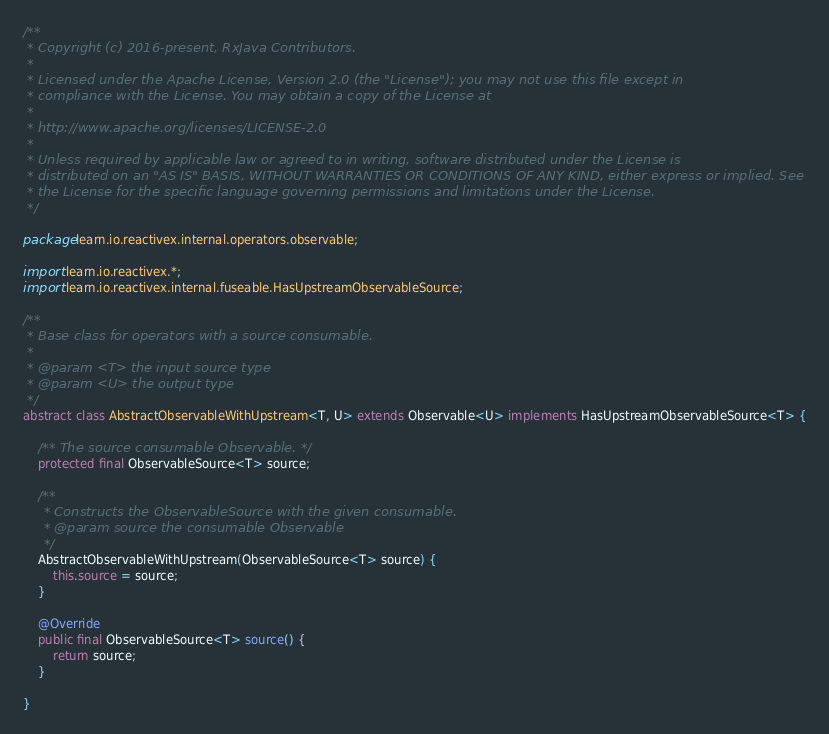Convert code to text. <code><loc_0><loc_0><loc_500><loc_500><_Java_>/**
 * Copyright (c) 2016-present, RxJava Contributors.
 *
 * Licensed under the Apache License, Version 2.0 (the "License"); you may not use this file except in
 * compliance with the License. You may obtain a copy of the License at
 *
 * http://www.apache.org/licenses/LICENSE-2.0
 *
 * Unless required by applicable law or agreed to in writing, software distributed under the License is
 * distributed on an "AS IS" BASIS, WITHOUT WARRANTIES OR CONDITIONS OF ANY KIND, either express or implied. See
 * the License for the specific language governing permissions and limitations under the License.
 */

package learn.io.reactivex.internal.operators.observable;

import learn.io.reactivex.*;
import learn.io.reactivex.internal.fuseable.HasUpstreamObservableSource;

/**
 * Base class for operators with a source consumable.
 *
 * @param <T> the input source type
 * @param <U> the output type
 */
abstract class AbstractObservableWithUpstream<T, U> extends Observable<U> implements HasUpstreamObservableSource<T> {

    /** The source consumable Observable. */
    protected final ObservableSource<T> source;

    /**
     * Constructs the ObservableSource with the given consumable.
     * @param source the consumable Observable
     */
    AbstractObservableWithUpstream(ObservableSource<T> source) {
        this.source = source;
    }

    @Override
    public final ObservableSource<T> source() {
        return source;
    }

}
</code> 